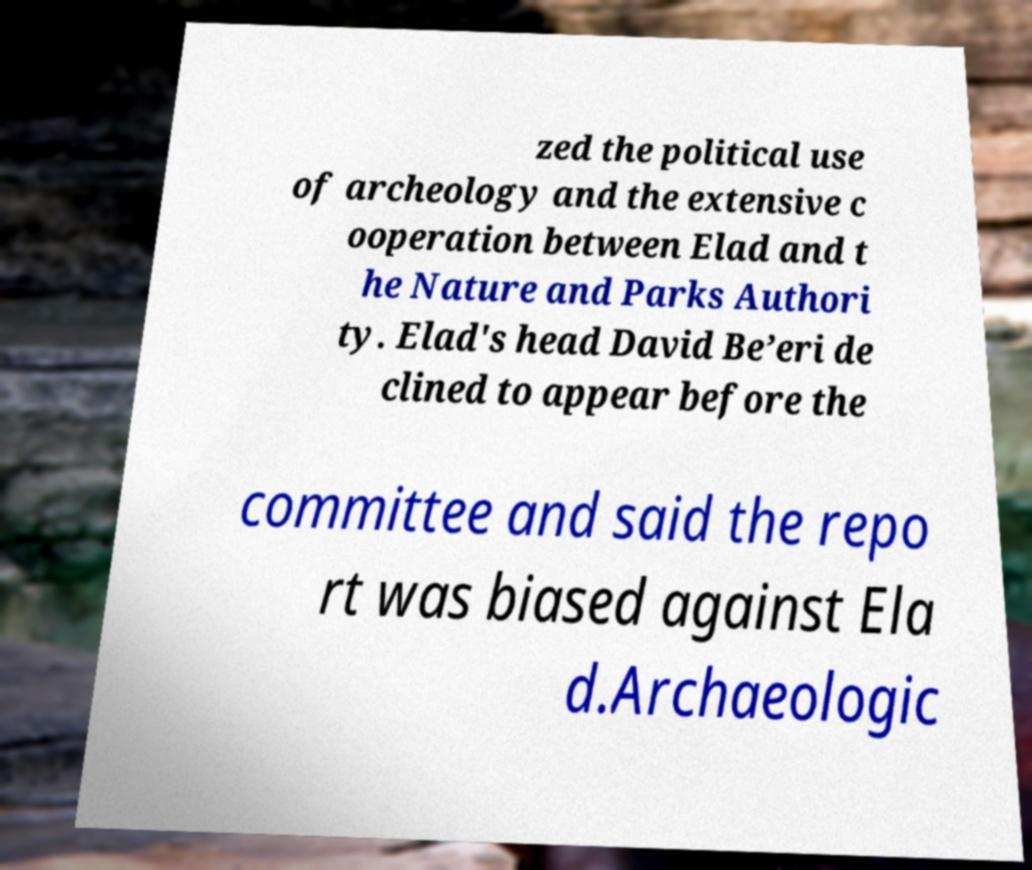There's text embedded in this image that I need extracted. Can you transcribe it verbatim? zed the political use of archeology and the extensive c ooperation between Elad and t he Nature and Parks Authori ty. Elad's head David Be’eri de clined to appear before the committee and said the repo rt was biased against Ela d.Archaeologic 